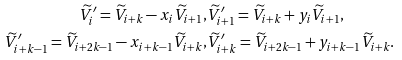<formula> <loc_0><loc_0><loc_500><loc_500>\widetilde { V } ^ { \prime } _ { i } = \widetilde { V } _ { i + k } - x _ { i } \widetilde { V } _ { i + 1 } , & \widetilde { V } ^ { \prime } _ { i + 1 } = \widetilde { V } _ { i + k } + y _ { i } \widetilde { V } _ { i + 1 } , \\ \widetilde { V } ^ { \prime } _ { i + k - 1 } = \widetilde { V } _ { i + 2 k - 1 } - x _ { i + k - 1 } \widetilde { V } _ { i + k } , & \widetilde { V } ^ { \prime } _ { i + k } = \widetilde { V } _ { i + 2 k - 1 } + y _ { i + k - 1 } \widetilde { V } _ { i + k } .</formula> 